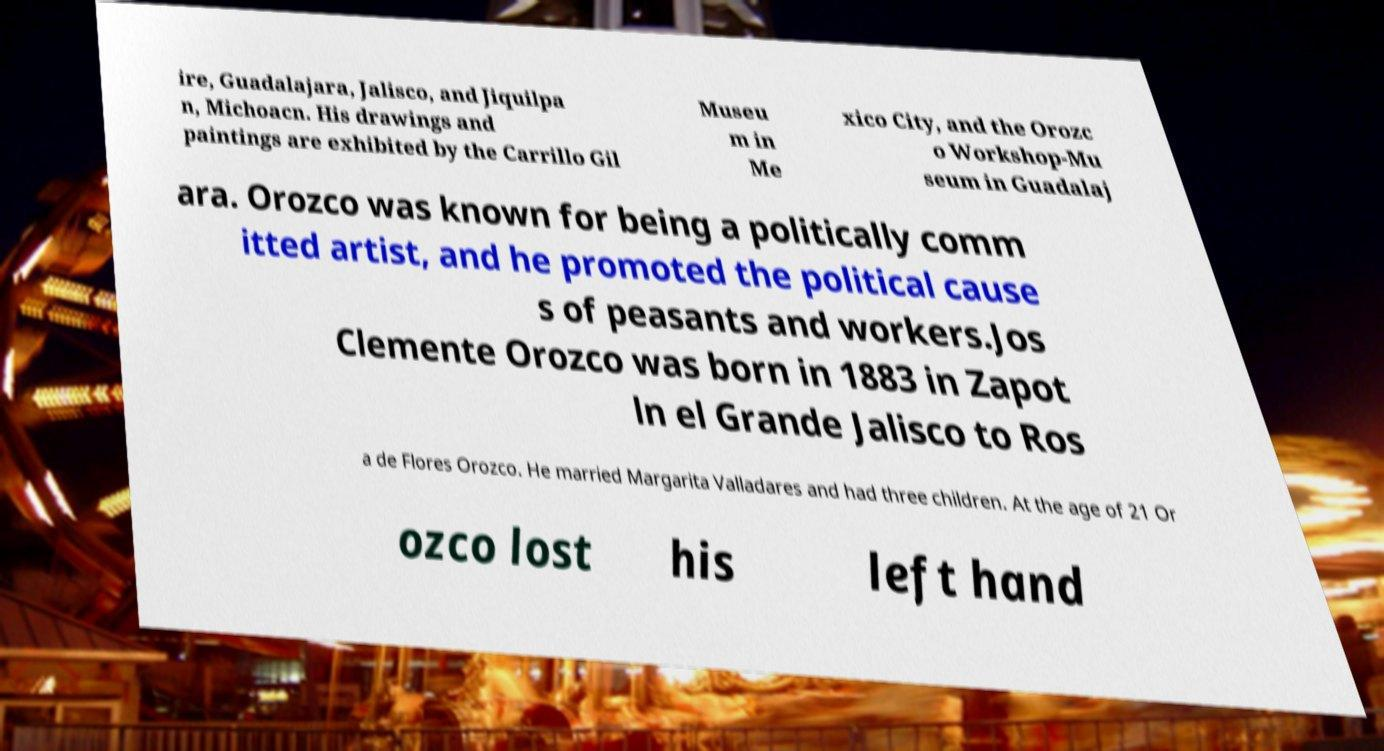Could you extract and type out the text from this image? ire, Guadalajara, Jalisco, and Jiquilpa n, Michoacn. His drawings and paintings are exhibited by the Carrillo Gil Museu m in Me xico City, and the Orozc o Workshop-Mu seum in Guadalaj ara. Orozco was known for being a politically comm itted artist, and he promoted the political cause s of peasants and workers.Jos Clemente Orozco was born in 1883 in Zapot ln el Grande Jalisco to Ros a de Flores Orozco. He married Margarita Valladares and had three children. At the age of 21 Or ozco lost his left hand 